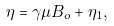<formula> <loc_0><loc_0><loc_500><loc_500>\eta = \gamma \mu B _ { o } + \eta _ { 1 } ,</formula> 